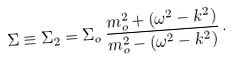<formula> <loc_0><loc_0><loc_500><loc_500>\Sigma \equiv \Sigma _ { 2 } = \Sigma _ { o } \, \frac { m _ { o } ^ { 2 } + ( \omega ^ { 2 } - k ^ { 2 } ) } { m _ { o } ^ { 2 } - ( \omega ^ { 2 } - k ^ { 2 } ) } \, .</formula> 